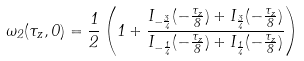Convert formula to latex. <formula><loc_0><loc_0><loc_500><loc_500>\omega _ { 2 } ( \tau _ { z } , 0 ) = \frac { 1 } { 2 } \left ( 1 + \frac { I _ { - \frac { 3 } { 4 } } ( - \frac { \tau _ { z } } { 8 } ) + I _ { \frac { 3 } { 4 } } ( - \frac { \tau _ { z } } { 8 } ) } { I _ { - \frac { 1 } { 4 } } ( - \frac { \tau _ { z } } { 8 } ) + I _ { \frac { 1 } { 4 } } ( - \frac { \tau _ { z } } { 8 } ) } \right )</formula> 